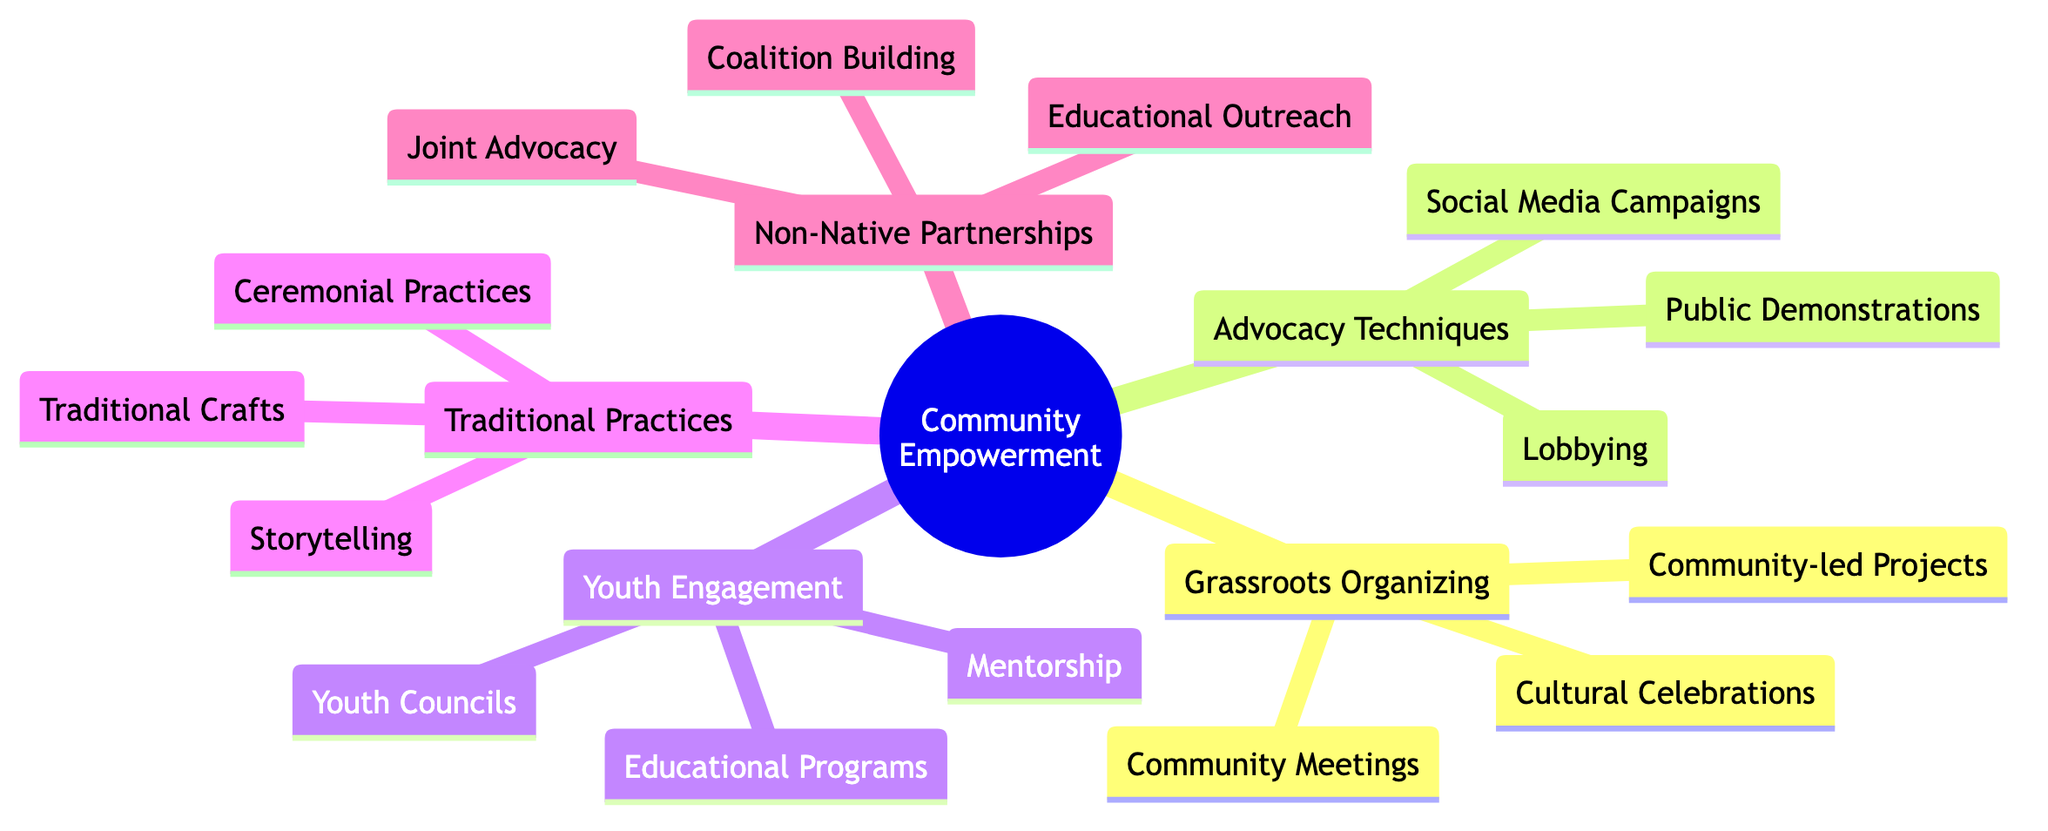What is one method of Grassroots Organizing? The diagram indicates "Community Meetings" as one method under the category of Grassroots Organizing. This node is connected directly under the Grassroots Organizing section.
Answer: Community Meetings How many types of Advocacy Techniques are listed? The diagram shows three nodes under Advocacy Techniques: Lobbying, Social Media Campaigns, and Public Demonstrations. Counting these provides the total for this category.
Answer: 3 What do Youth Councils provide to young people? The diagram states that Youth Councils give young people a voice in community matters, as indicated in the Youth Engagement Initiatives section. This is a direct description from the node itself.
Answer: A voice Which node is directly connected to the Role of Traditional Practices? The diagram connects three nodes directly under the Role of Traditional Practices: Storytelling, Ceremonial Practices, and Traditional Crafts. The first one, Storytelling, is the answer for this connection.
Answer: Storytelling How are Joint Advocacy and Coalition Building related? Both nodes are part of the Partnerships with Non-Native Allies section, indicating that these advocacy strategies are grouped to suggest a collective approach to community empowerment. The relationship indicates they are components of the same overarching strategy.
Answer: They are both under Partnerships with Non-Native Allies What is the focus of Educational Outreach as a strategy? The diagram labels Educational Outreach as a program designed to educate non-Native allies about Native issues and history. This provides the essential focus of this node.
Answer: Educate non-Native allies How many nodes are under Youth Engagement Initiatives? There are three specific nodes under Youth Engagement Initiatives: Youth Councils, Educational Programs, and Mentorship. Counting the nodes gives the answer.
Answer: 3 What is an example of a Community-led Project? The diagram mentions "Initiatives such as community gardens or clean-up drives" as examples under Community-led Projects, indicating specific activities that are community-driven.
Answer: Community gardens or clean-up drives 